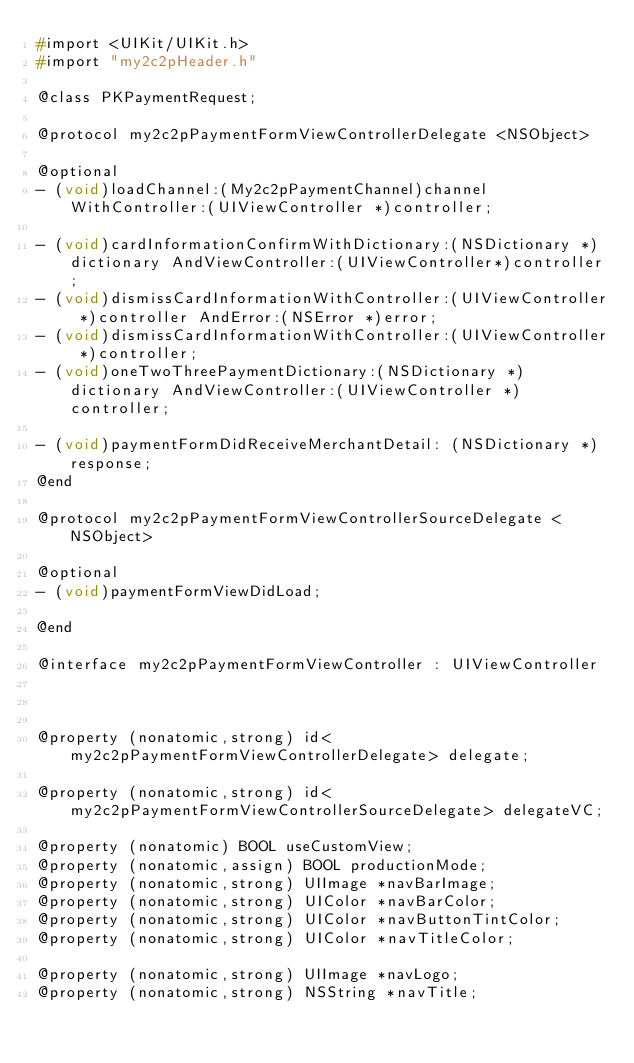<code> <loc_0><loc_0><loc_500><loc_500><_C_>#import <UIKit/UIKit.h>
#import "my2c2pHeader.h"

@class PKPaymentRequest;

@protocol my2c2pPaymentFormViewControllerDelegate <NSObject>

@optional
- (void)loadChannel:(My2c2pPaymentChannel)channel WithController:(UIViewController *)controller;

- (void)cardInformationConfirmWithDictionary:(NSDictionary *)dictionary AndViewController:(UIViewController*)controller;
- (void)dismissCardInformationWithController:(UIViewController *)controller AndError:(NSError *)error;
- (void)dismissCardInformationWithController:(UIViewController *)controller;
- (void)oneTwoThreePaymentDictionary:(NSDictionary *)dictionary AndViewController:(UIViewController *)controller;

- (void)paymentFormDidReceiveMerchantDetail: (NSDictionary *)response;
@end

@protocol my2c2pPaymentFormViewControllerSourceDelegate <NSObject>

@optional
- (void)paymentFormViewDidLoad;

@end

@interface my2c2pPaymentFormViewController : UIViewController



@property (nonatomic,strong) id<my2c2pPaymentFormViewControllerDelegate> delegate;

@property (nonatomic,strong) id<my2c2pPaymentFormViewControllerSourceDelegate> delegateVC;

@property (nonatomic) BOOL useCustomView;
@property (nonatomic,assign) BOOL productionMode;
@property (nonatomic,strong) UIImage *navBarImage;
@property (nonatomic,strong) UIColor *navBarColor;
@property (nonatomic,strong) UIColor *navButtonTintColor;
@property (nonatomic,strong) UIColor *navTitleColor;

@property (nonatomic,strong) UIImage *navLogo;
@property (nonatomic,strong) NSString *navTitle;

</code> 